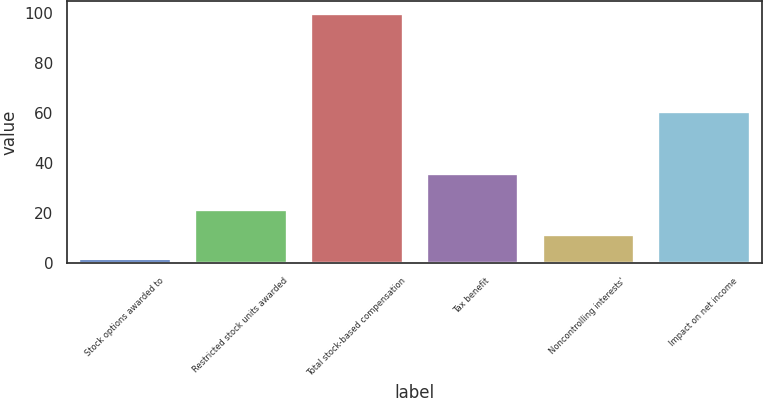<chart> <loc_0><loc_0><loc_500><loc_500><bar_chart><fcel>Stock options awarded to<fcel>Restricted stock units awarded<fcel>Total stock-based compensation<fcel>Tax benefit<fcel>Noncontrolling interests'<fcel>Impact on net income<nl><fcel>2<fcel>21.6<fcel>100<fcel>36<fcel>11.8<fcel>61<nl></chart> 